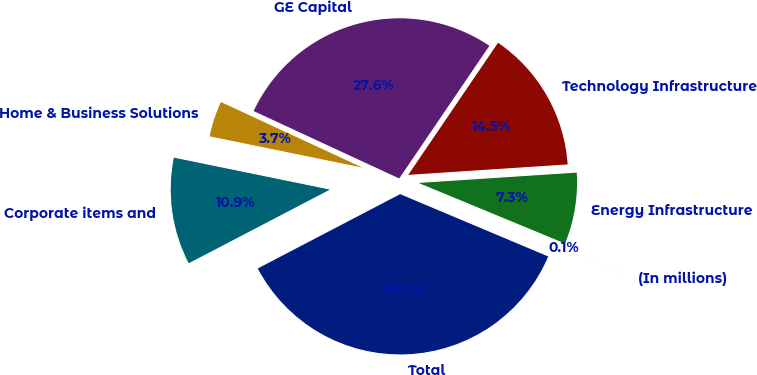<chart> <loc_0><loc_0><loc_500><loc_500><pie_chart><fcel>(In millions)<fcel>Energy Infrastructure<fcel>Technology Infrastructure<fcel>GE Capital<fcel>Home & Business Solutions<fcel>Corporate items and<fcel>Total<nl><fcel>0.1%<fcel>7.28%<fcel>14.46%<fcel>27.6%<fcel>3.69%<fcel>10.87%<fcel>36.01%<nl></chart> 